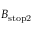<formula> <loc_0><loc_0><loc_500><loc_500>B _ { s t o p 2 }</formula> 